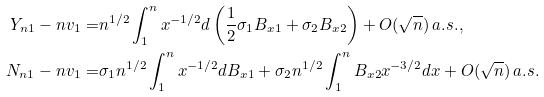<formula> <loc_0><loc_0><loc_500><loc_500>Y _ { n 1 } - n v _ { 1 } = & n ^ { 1 / 2 } \int _ { 1 } ^ { n } x ^ { - 1 / 2 } d \left ( \frac { 1 } { 2 } \sigma _ { 1 } B _ { x 1 } + \sigma _ { 2 } B _ { x 2 } \right ) + O ( \sqrt { n } ) \, a . s . , \\ N _ { n 1 } - n v _ { 1 } = & \sigma _ { 1 } n ^ { 1 / 2 } \int _ { 1 } ^ { n } x ^ { - 1 / 2 } d B _ { x 1 } + \sigma _ { 2 } n ^ { 1 / 2 } \int _ { 1 } ^ { n } B _ { x 2 } x ^ { - 3 / 2 } d x + O ( \sqrt { n } ) \, a . s .</formula> 